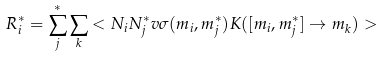Convert formula to latex. <formula><loc_0><loc_0><loc_500><loc_500>R _ { i } ^ { * } = \sum _ { j } ^ { * } \sum _ { k } < N _ { i } N _ { j } ^ { * } v \sigma ( m _ { i } , m _ { j } ^ { * } ) K ( [ m _ { i } , m _ { j } ^ { * } ] \rightarrow m _ { k } ) ></formula> 